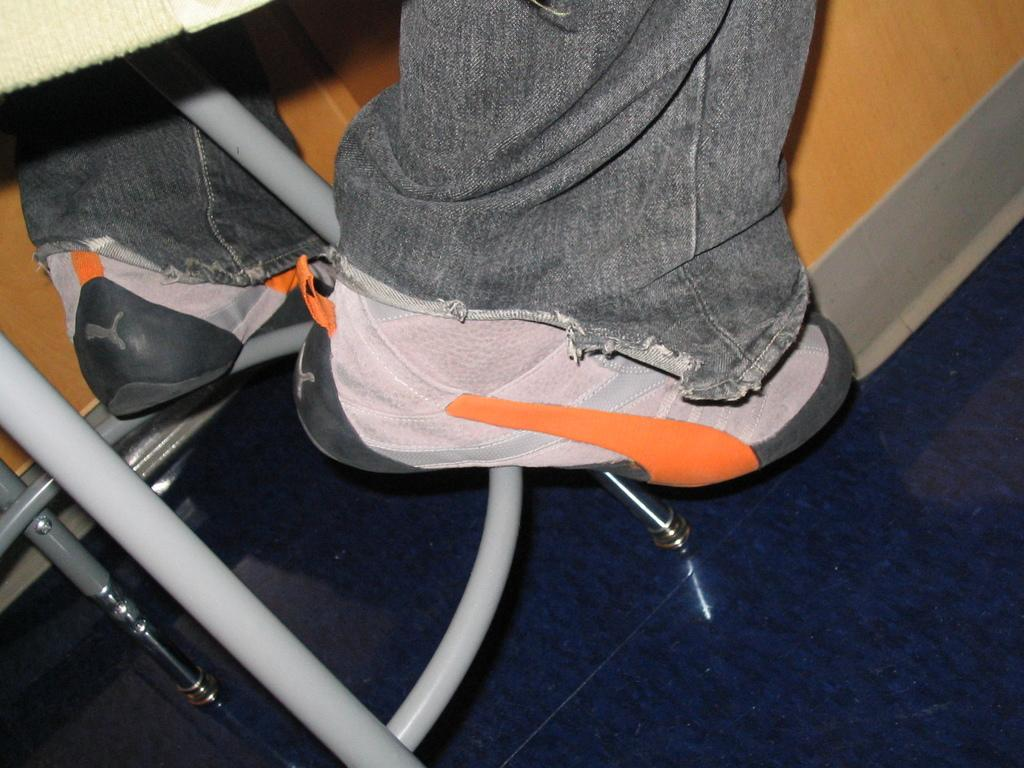What type of surface is visible in the image? There is a floor visible in the image. What objects can be seen in the image that are long and thin? There are rods in the image. What type of footwear is present in the image? There are shoes in the image. What material is present in the image that can be used for covering or wrapping? There is cloth in the image. What type of object can be seen in the background of the image that is made of wood? There is a wooden object in the background of the image. What type of plantation can be seen growing in the image? There is no plantation present in the image. How many times has the person bitten the shoes in the image? There is no indication of anyone biting the shoes in the image. 